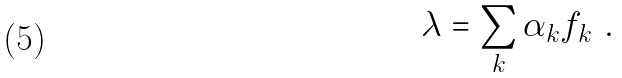<formula> <loc_0><loc_0><loc_500><loc_500>\lambda = \sum _ { k } \alpha _ { k } f _ { k } \ .</formula> 